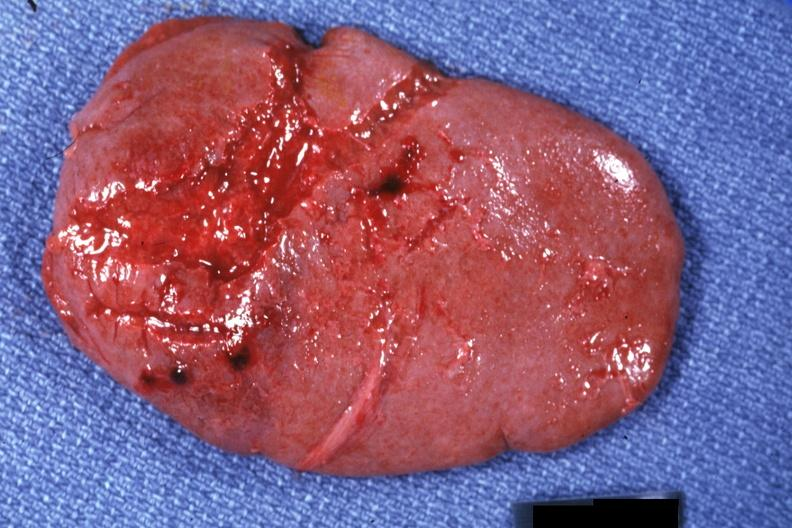s malignant adenoma present?
Answer the question using a single word or phrase. No 